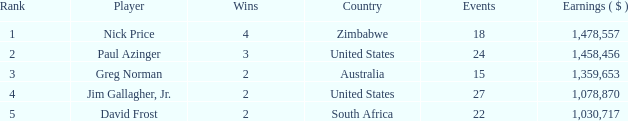How many events have earnings less than 1,030,717? 0.0. 